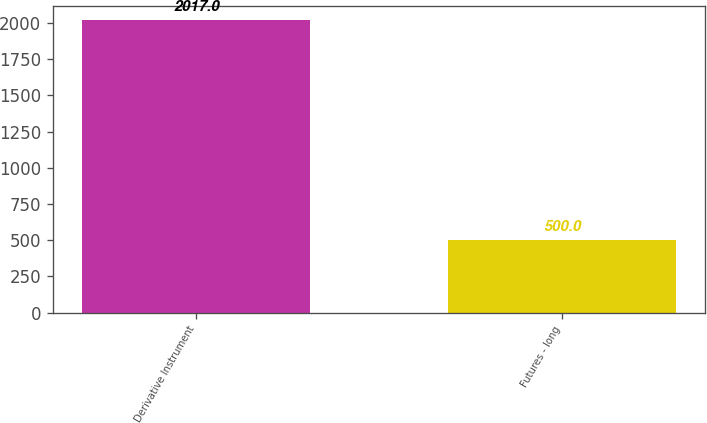Convert chart. <chart><loc_0><loc_0><loc_500><loc_500><bar_chart><fcel>Derivative Instrument<fcel>Futures - long<nl><fcel>2017<fcel>500<nl></chart> 